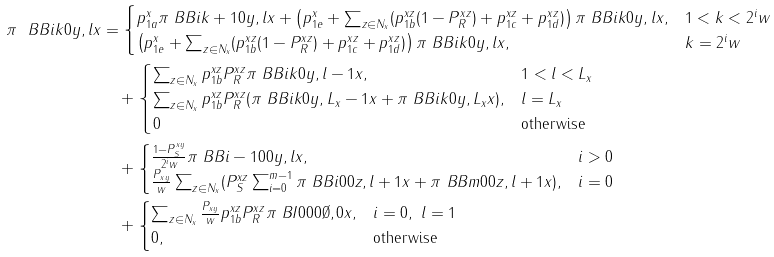<formula> <loc_0><loc_0><loc_500><loc_500>\pi \ B { B } { i } { k } { 0 } { y , l } { x } & = \begin{cases} p ^ { x } _ { 1 a } \pi \ B { B } { i } { k + 1 } { 0 } { y , l } { x } + \left ( p ^ { x } _ { 1 e } + \sum _ { z \in N _ { x } } ( p ^ { x z } _ { 1 b } ( 1 - P ^ { x z } _ { R } ) + p ^ { x z } _ { 1 c } + p ^ { x z } _ { 1 d } ) \right ) \pi \ B { B } { i } { k } { 0 } { y , l } { x } , & 1 < k < 2 ^ { i } w \\ \left ( p ^ { x } _ { 1 e } + \sum _ { z \in N _ { x } } ( p ^ { x z } _ { 1 b } ( 1 - P ^ { x z } _ { R } ) + p ^ { x z } _ { 1 c } + p ^ { x z } _ { 1 d } ) \right ) \pi \ B { B } { i } { k } { 0 } { y , l } { x } , & k = 2 ^ { i } w \end{cases} \\ & \quad + \begin{cases} \sum _ { z \in N _ { x } } p ^ { x z } _ { 1 b } P ^ { x z } _ { R } \pi \ B { B } { i } { k } { 0 } { y , l - 1 } { x } , & 1 < l < L _ { x } \\ \sum _ { z \in N _ { x } } p ^ { x z } _ { 1 b } P ^ { x z } _ { R } ( \pi \ B { B } { i } { k } { 0 } { y , L _ { x } - 1 } { x } + \pi \ B { B } { i } { k } { 0 } { y , L _ { x } } { x } ) , & l = L _ { x } \\ 0 & \text {otherwise} \end{cases} \\ & \quad + \begin{cases} \frac { 1 - P ^ { x y } _ { S } } { 2 ^ { i } w } \pi \ B { B } { i - 1 } { 0 } { 0 } { y , l } { x } , & i > 0 \\ \frac { P _ { x y } } { w } \sum _ { z \in N _ { x } } ( P ^ { x z } _ { S } \sum _ { i = 0 } ^ { m - 1 } \pi \ B { B } { i } { 0 } { 0 } { z , l + 1 } { x } + \pi \ B { B } { m } { 0 } { 0 } { z , l + 1 } { x } ) , & i = 0 \\ \end{cases} \\ & \quad + \begin{cases} \sum _ { z \in N _ { x } } \frac { P _ { x y } } { w } p ^ { x z } _ { 1 b } P ^ { x z } _ { R } \pi \ B { I } { 0 } { 0 } { 0 } { \emptyset , 0 } { x } , & i = 0 , \ l = 1 \\ 0 , & \text {otherwise} \end{cases}</formula> 